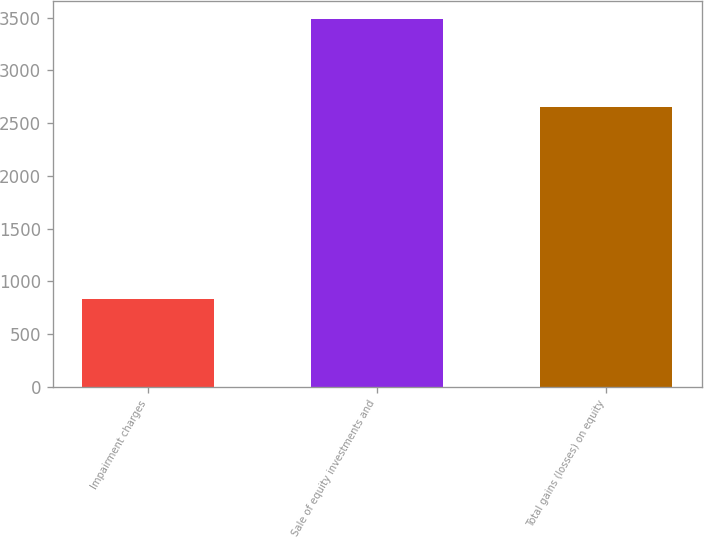Convert chart. <chart><loc_0><loc_0><loc_500><loc_500><bar_chart><fcel>Impairment charges<fcel>Sale of equity investments and<fcel>Total gains (losses) on equity<nl><fcel>833<fcel>3484<fcel>2651<nl></chart> 